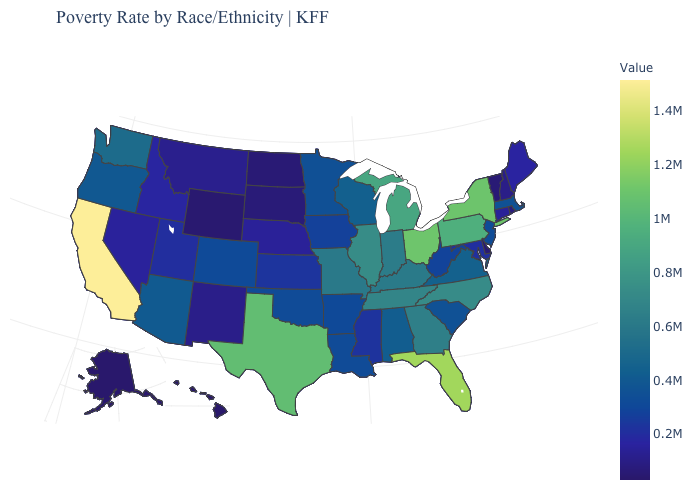Among the states that border Nebraska , which have the highest value?
Short answer required. Missouri. Does New York have the highest value in the Northeast?
Quick response, please. Yes. Does Kansas have the highest value in the USA?
Write a very short answer. No. Among the states that border Washington , which have the lowest value?
Short answer required. Idaho. Does New York have the highest value in the Northeast?
Give a very brief answer. Yes. 